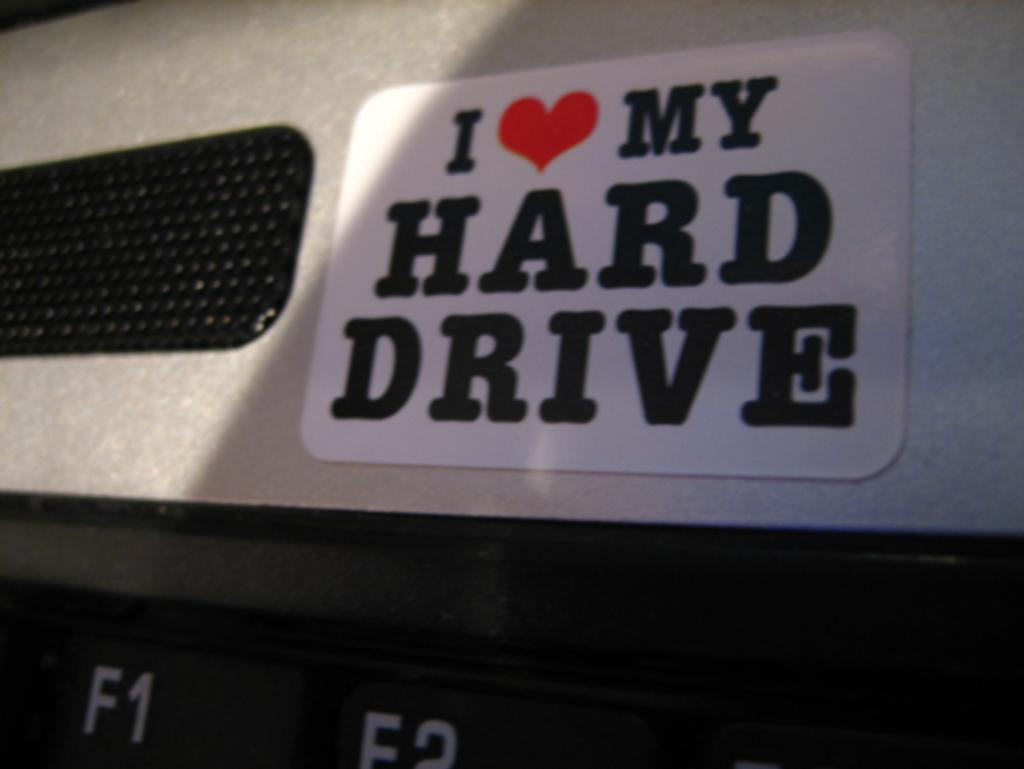What electronic device is visible in the image? There is a laptop in the image. What is on the laptop? The laptop has a sticker on it. What does the sticker say? The sticker says "I love my hard drive." What type of music can be heard coming from the basket in the image? There is no basket present in the image, and therefore no music can be heard from it. 